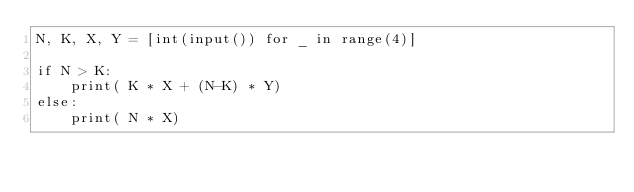Convert code to text. <code><loc_0><loc_0><loc_500><loc_500><_Python_>N, K, X, Y = [int(input()) for _ in range(4)]

if N > K:
    print( K * X + (N-K) * Y)
else:
    print( N * X)</code> 